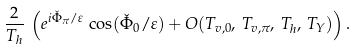Convert formula to latex. <formula><loc_0><loc_0><loc_500><loc_500>\frac { 2 } { T _ { h } } \, \left ( e ^ { i \check { \Phi } _ { \pi } / \varepsilon } \, \cos ( \check { \Phi } _ { 0 } / \varepsilon ) + O ( T _ { v , 0 } , \, T _ { v , \pi } , \, T _ { h } , \, T _ { Y } ) \right ) .</formula> 